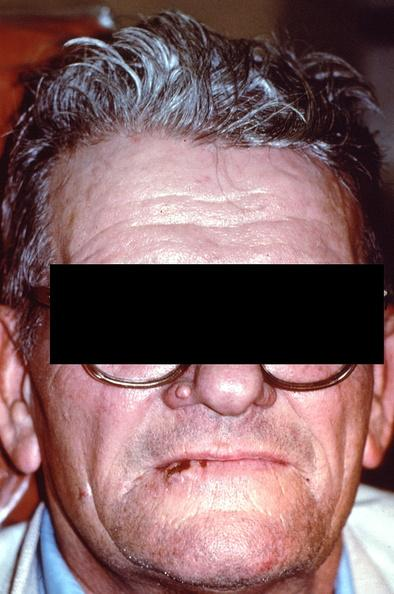s gastrointestinal present?
Answer the question using a single word or phrase. Yes 